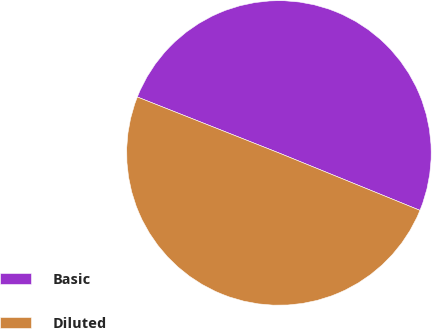Convert chart to OTSL. <chart><loc_0><loc_0><loc_500><loc_500><pie_chart><fcel>Basic<fcel>Diluted<nl><fcel>50.16%<fcel>49.84%<nl></chart> 